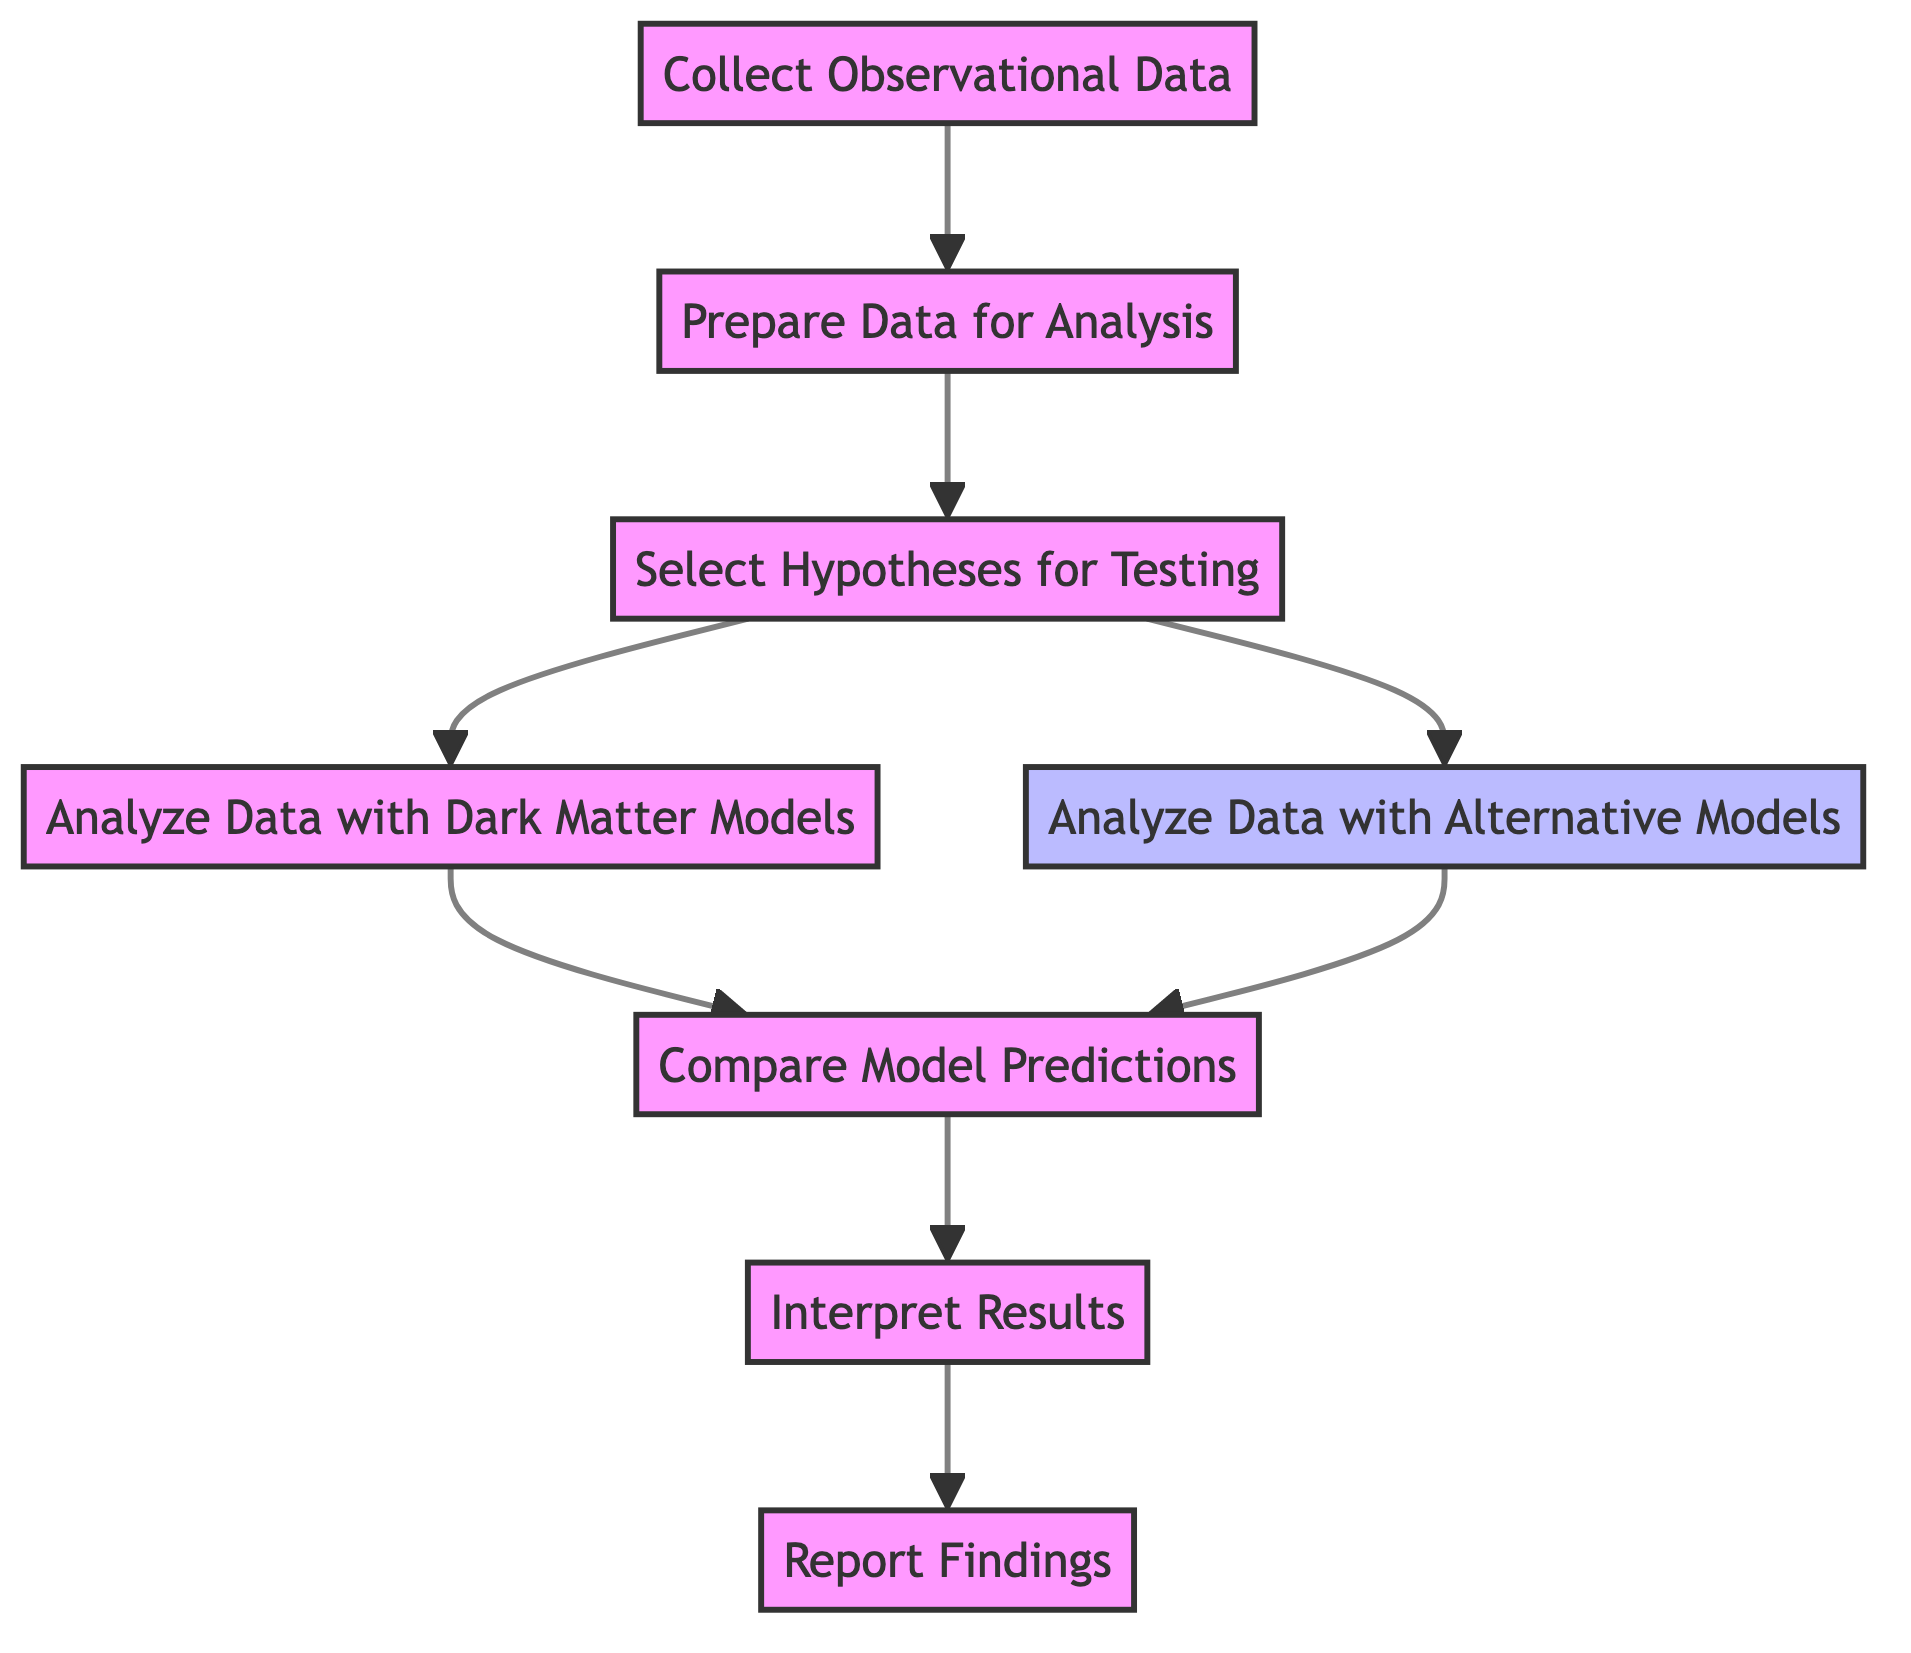What is the first step in the diagram? The first step in the diagram is 'Collect Observational Data', which can be identified as the starting node connected to the flow.
Answer: Collect Observational Data How many analysis types are there for testing hypotheses? There are two analysis types: 'Analyze Data with Dark Matter Models' and 'Analyze Data with Alternative Models', which branch from the 'Select Hypotheses for Testing' node.
Answer: Two What node follows 'Prepare Data for Analysis'? The node that follows 'Prepare Data for Analysis' is 'Select Hypotheses for Testing', which directly connects to it in the flowchart.
Answer: Select Hypotheses for Testing Which models are compared in the final step? The final step compares model predictions from 'Analyze Data with Dark Matter Models' and 'Analyze Data with Alternative Models', as indicated in 'Compare Model Predictions'.
Answer: Dark Matter Models and Alternative Models What is the outcome of the 'Interpret Results' step? The outcome of the 'Interpret Results' step is to critically analyze the findings to determine which model better explains the observed galaxy rotations. This involves scrutinizing the necessity of dark matter.
Answer: Critically analyze the findings How many total steps are there in this analysis process? Counting each step from 'Collect Observational Data' to 'Report Findings', there are a total of eight steps in the analysis process.
Answer: Eight What is the role of the 'Select Hypotheses for Testing' node? The role of the 'Select Hypotheses for Testing' node is to identify and define alternative galaxy rotation models, indicating its importance as a decision point in the analysis.
Answer: Identify models Which node represents the reporting stage in the analysis process? The node that represents the reporting stage in the analysis process is 'Report Findings', where results are documented and published.
Answer: Report Findings What are the two approaches in step 3? The two approaches in step 3 are 'dark matter models' and 'modified Newtonian dynamics'. This is a critical decision point where multiple theories are considered for testing.
Answer: Dark Matter and MOND 